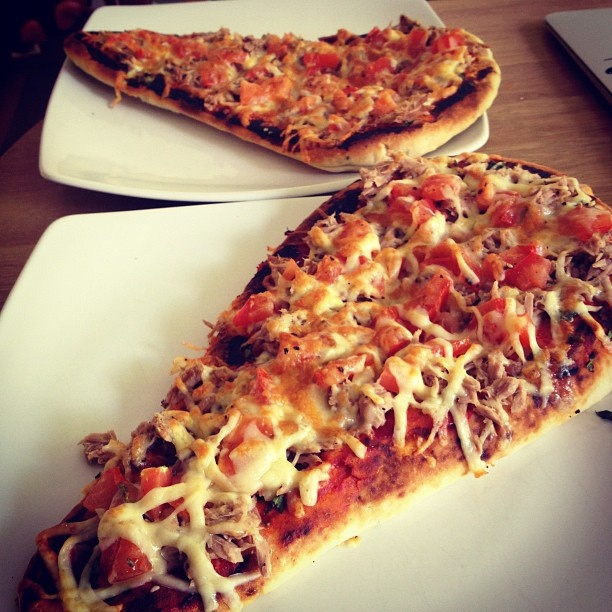Describe the objects in this image and their specific colors. I can see pizza in black, tan, brown, maroon, and khaki tones, pizza in black, brown, and maroon tones, and dining table in black, maroon, and brown tones in this image. 